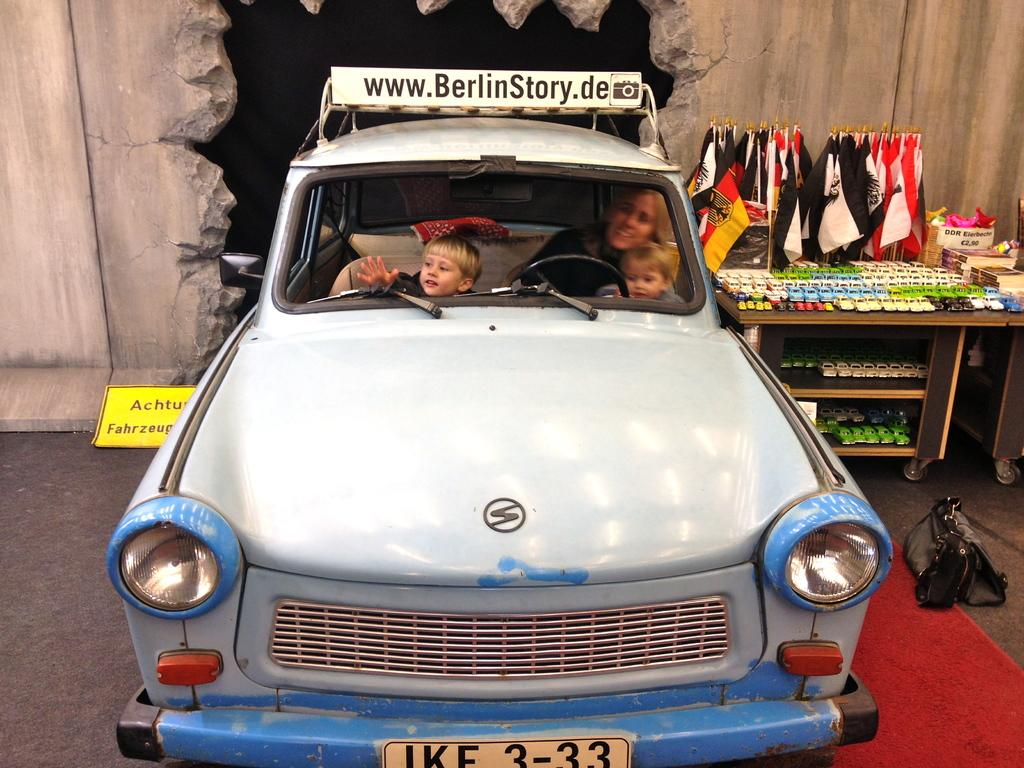Who is present in the image? There is a woman and two kids in the image. Where are the woman and kids located? They are inside a vehicle in the image. What can be seen outside the vehicle? The image shows a road and a wall. What is on the table in the image? There are toys on the table in the image. Are there any symbols or decorations visible? Yes, there are flags in the image. What is the interest rate for the loan taken out by the woman in the image? There is no information about a loan or interest rate in the image. 